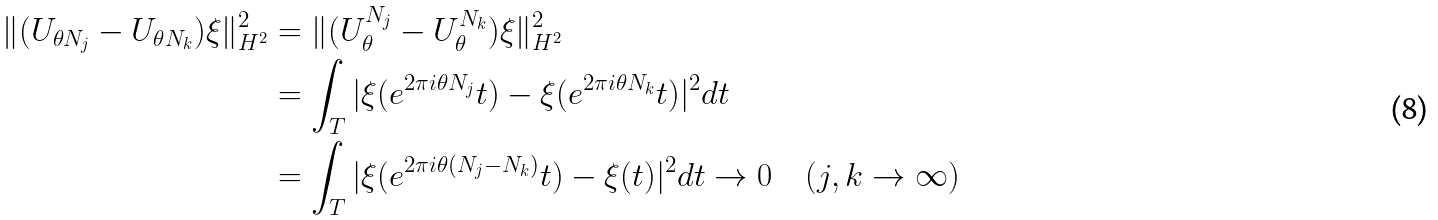<formula> <loc_0><loc_0><loc_500><loc_500>\| ( U _ { \theta N _ { j } } - U _ { \theta N _ { k } } ) \xi \| _ { H ^ { 2 } } ^ { 2 } & = \| ( U _ { \theta } ^ { N _ { j } } - U _ { \theta } ^ { N _ { k } } ) \xi \| _ { H ^ { 2 } } ^ { 2 } \\ & = \int _ { T } | \xi ( e ^ { 2 \pi i \theta N _ { j } } t ) - \xi ( e ^ { 2 \pi i \theta N _ { k } } t ) | ^ { 2 } d t \\ & = \int _ { T } | \xi ( e ^ { 2 \pi i \theta ( N _ { j } - N _ { k } ) } t ) - \xi ( t ) | ^ { 2 } d t \to 0 \quad ( j , k \to \infty )</formula> 